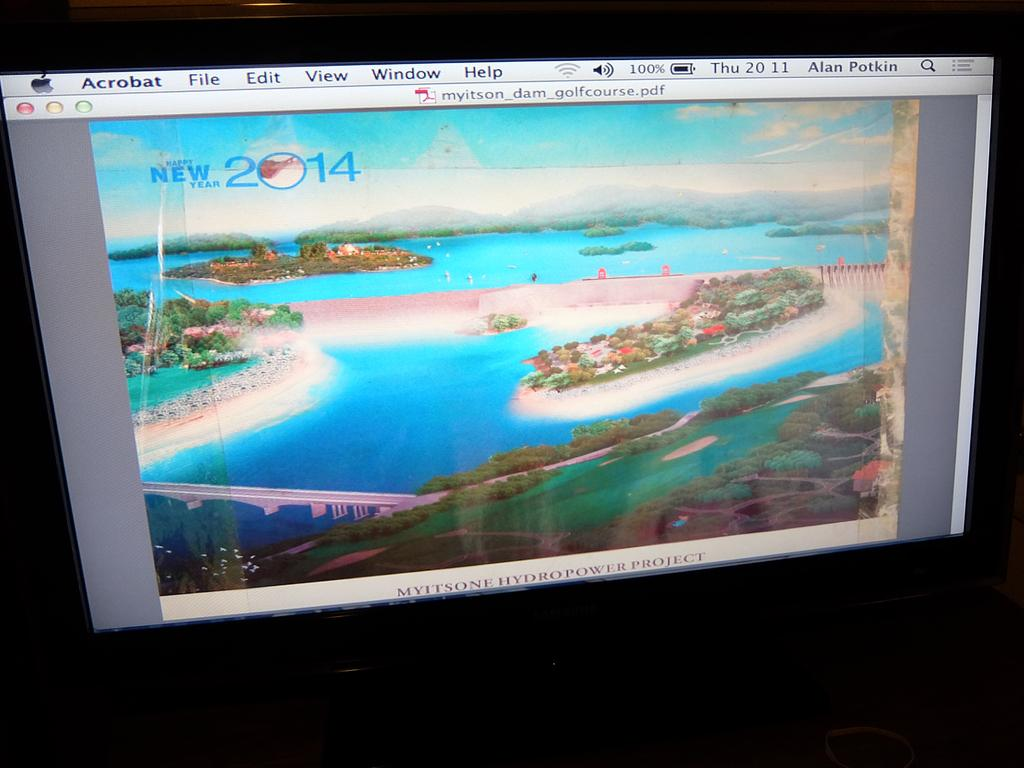<image>
Write a terse but informative summary of the picture. A scene of water and new 2014 is displayed on the screen. 